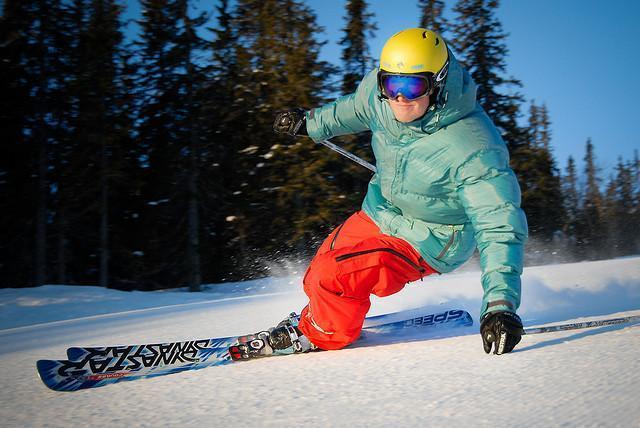How many donuts are in the box?
Give a very brief answer. 0. 